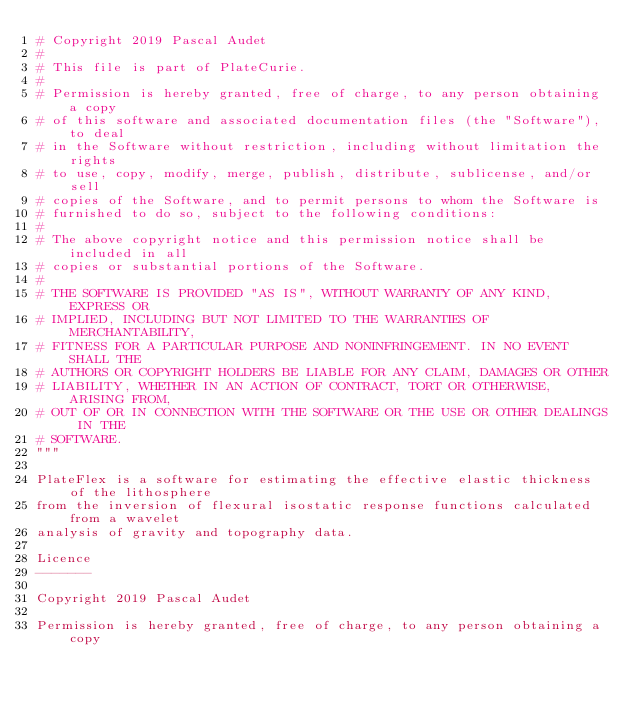Convert code to text. <code><loc_0><loc_0><loc_500><loc_500><_Python_># Copyright 2019 Pascal Audet
#
# This file is part of PlateCurie.
#
# Permission is hereby granted, free of charge, to any person obtaining a copy
# of this software and associated documentation files (the "Software"), to deal
# in the Software without restriction, including without limitation the rights
# to use, copy, modify, merge, publish, distribute, sublicense, and/or sell
# copies of the Software, and to permit persons to whom the Software is
# furnished to do so, subject to the following conditions:
#
# The above copyright notice and this permission notice shall be included in all
# copies or substantial portions of the Software.
#
# THE SOFTWARE IS PROVIDED "AS IS", WITHOUT WARRANTY OF ANY KIND, EXPRESS OR
# IMPLIED, INCLUDING BUT NOT LIMITED TO THE WARRANTIES OF MERCHANTABILITY,
# FITNESS FOR A PARTICULAR PURPOSE AND NONINFRINGEMENT. IN NO EVENT SHALL THE
# AUTHORS OR COPYRIGHT HOLDERS BE LIABLE FOR ANY CLAIM, DAMAGES OR OTHER
# LIABILITY, WHETHER IN AN ACTION OF CONTRACT, TORT OR OTHERWISE, ARISING FROM,
# OUT OF OR IN CONNECTION WITH THE SOFTWARE OR THE USE OR OTHER DEALINGS IN THE
# SOFTWARE.
"""

PlateFlex is a software for estimating the effective elastic thickness of the lithosphere
from the inversion of flexural isostatic response functions calculated from a wavelet
analysis of gravity and topography data.

Licence
-------

Copyright 2019 Pascal Audet

Permission is hereby granted, free of charge, to any person obtaining a copy</code> 